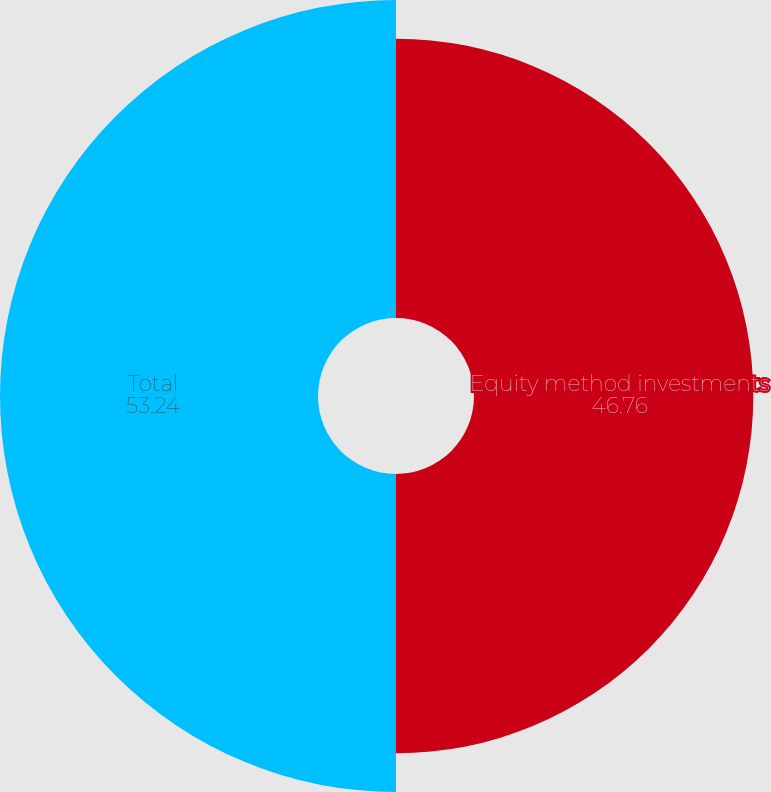Convert chart to OTSL. <chart><loc_0><loc_0><loc_500><loc_500><pie_chart><fcel>Equity method investments<fcel>Total<nl><fcel>46.76%<fcel>53.24%<nl></chart> 